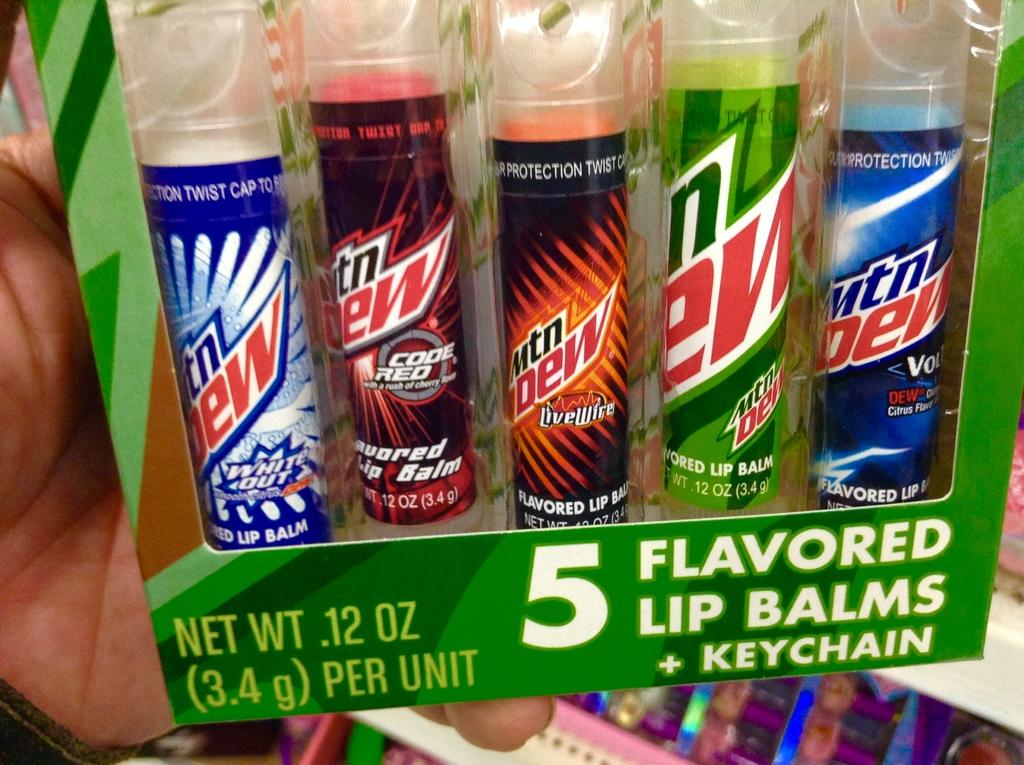<image>
Describe the image concisely. A case of Mountain Dew Lip Balms and a keychain 